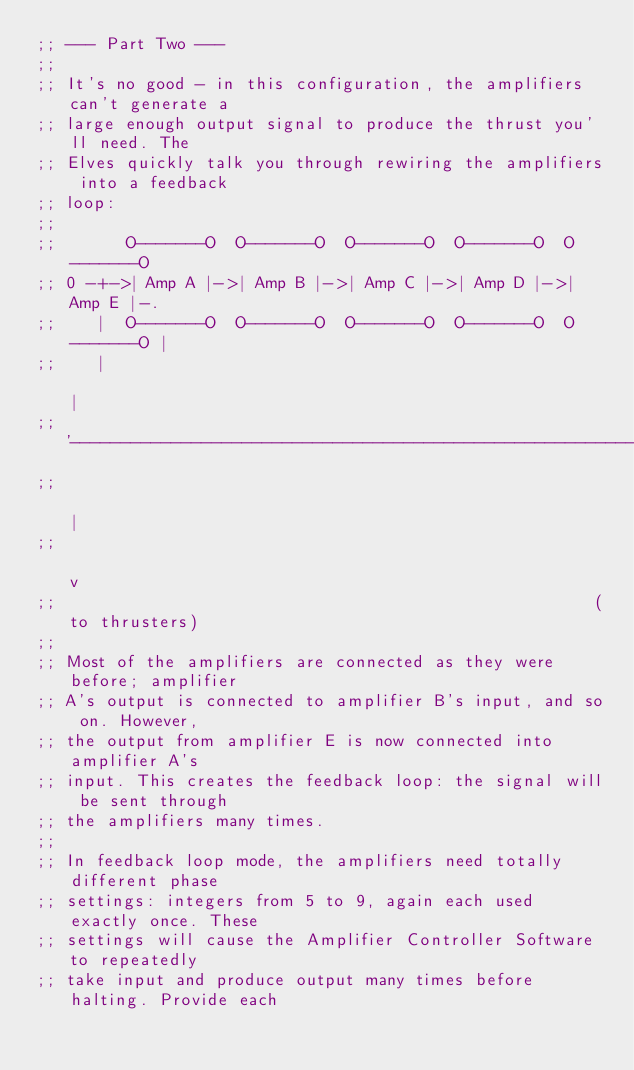Convert code to text. <code><loc_0><loc_0><loc_500><loc_500><_Scheme_>;; --- Part Two ---
;; 
;; It's no good - in this configuration, the amplifiers can't generate a
;; large enough output signal to produce the thrust you'll need. The
;; Elves quickly talk you through rewiring the amplifiers into a feedback
;; loop:
;; 
;;       O-------O  O-------O  O-------O  O-------O  O-------O
;; 0 -+->| Amp A |->| Amp B |->| Amp C |->| Amp D |->| Amp E |-.
;;    |  O-------O  O-------O  O-------O  O-------O  O-------O |
;;    |                                                        |
;;    '--------------------------------------------------------+
;;                                                             |
;;                                                             v
;;                                                      (to thrusters)
;; 
;; Most of the amplifiers are connected as they were before; amplifier
;; A's output is connected to amplifier B's input, and so on. However,
;; the output from amplifier E is now connected into amplifier A's
;; input. This creates the feedback loop: the signal will be sent through
;; the amplifiers many times.
;; 
;; In feedback loop mode, the amplifiers need totally different phase
;; settings: integers from 5 to 9, again each used exactly once. These
;; settings will cause the Amplifier Controller Software to repeatedly
;; take input and produce output many times before halting. Provide each</code> 